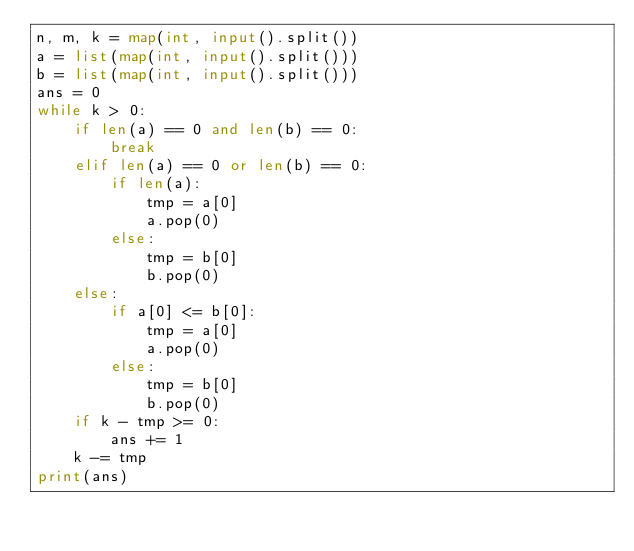<code> <loc_0><loc_0><loc_500><loc_500><_Python_>n, m, k = map(int, input().split())
a = list(map(int, input().split()))
b = list(map(int, input().split()))
ans = 0
while k > 0:
    if len(a) == 0 and len(b) == 0:
        break
    elif len(a) == 0 or len(b) == 0:
        if len(a):
            tmp = a[0]
            a.pop(0)
        else:
            tmp = b[0]
            b.pop(0)
    else:
        if a[0] <= b[0]:
            tmp = a[0]
            a.pop(0)
        else:
            tmp = b[0]
            b.pop(0)
    if k - tmp >= 0:
        ans += 1
    k -= tmp
print(ans)</code> 